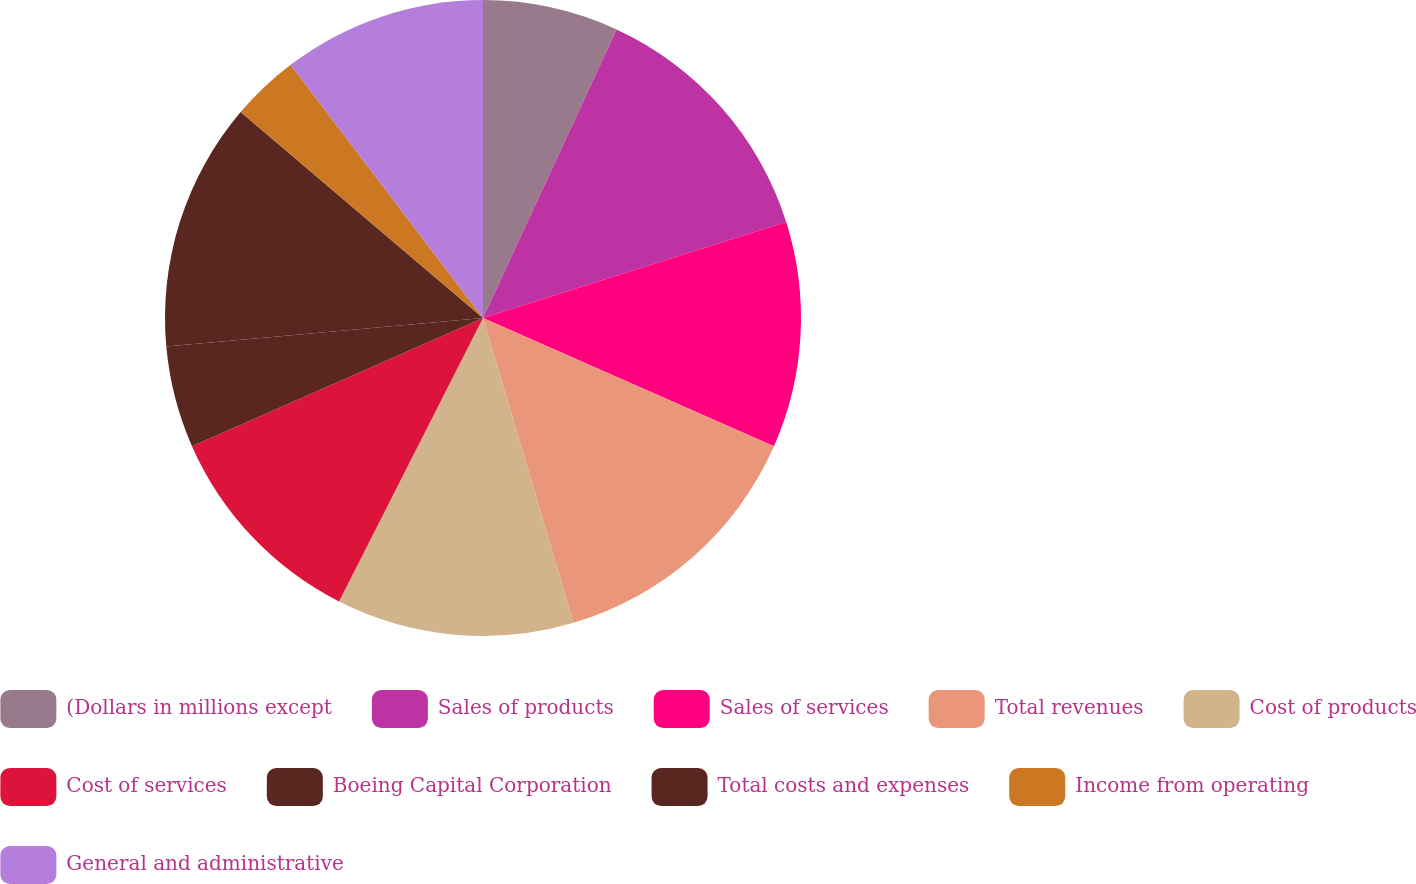Convert chart to OTSL. <chart><loc_0><loc_0><loc_500><loc_500><pie_chart><fcel>(Dollars in millions except<fcel>Sales of products<fcel>Sales of services<fcel>Total revenues<fcel>Cost of products<fcel>Cost of services<fcel>Boeing Capital Corporation<fcel>Total costs and expenses<fcel>Income from operating<fcel>General and administrative<nl><fcel>6.9%<fcel>13.22%<fcel>11.49%<fcel>13.79%<fcel>12.07%<fcel>10.92%<fcel>5.17%<fcel>12.64%<fcel>3.45%<fcel>10.34%<nl></chart> 